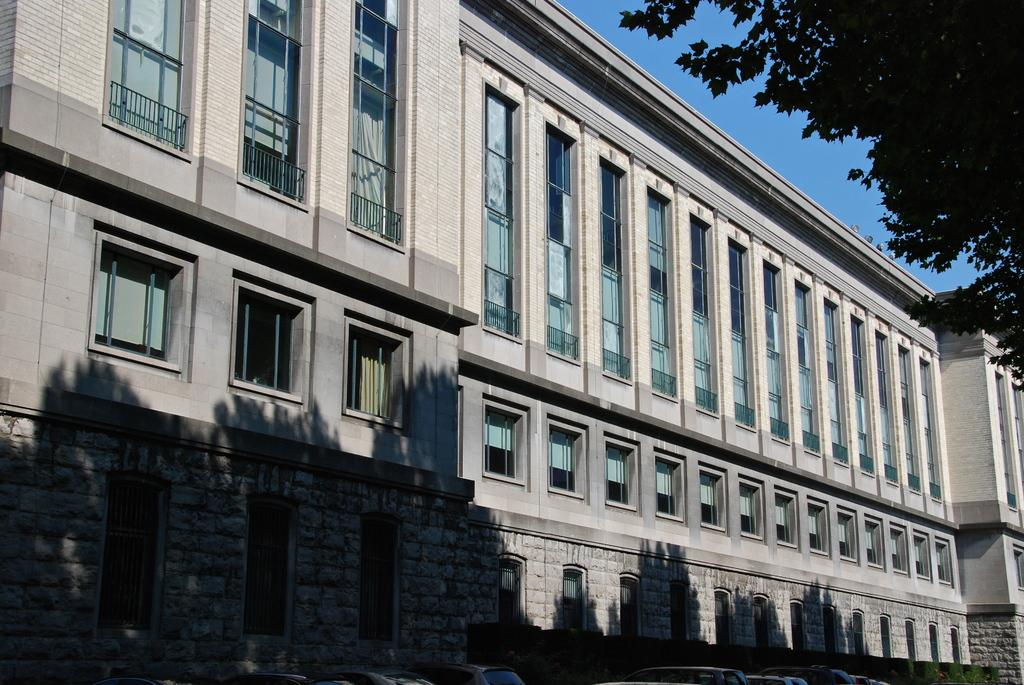What is the main subject in the center of the image? There is a building in the center of the image. What can be seen in the top right corner of the image? There is a tree in the top right corner of the image. What part of the natural environment is visible in the image? The sky is visible in the image. What type of breakfast is being served in the image? There is no breakfast present in the image; it features a building, a tree, and the sky. What song is being sung by the scarecrow in the image? There is no scarecrow present in the image, so it is not possible to determine what song might be sung. 